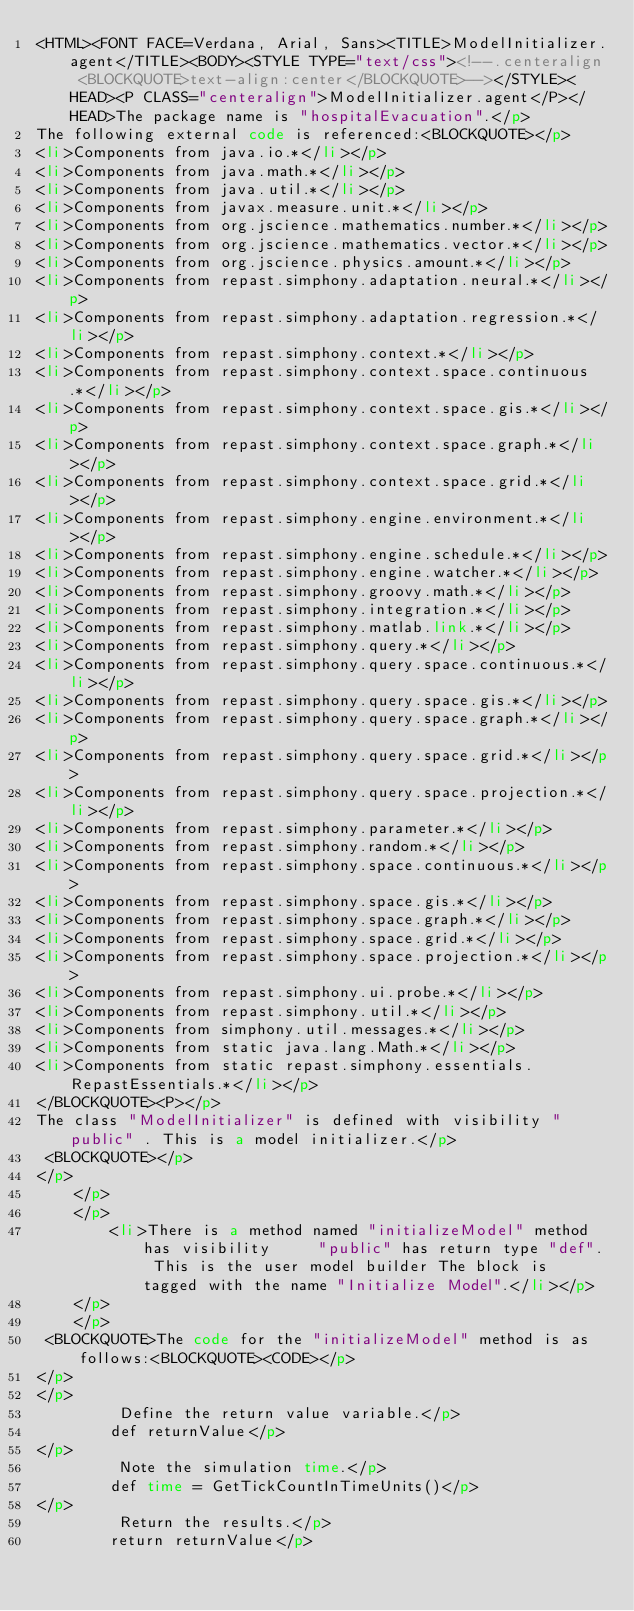Convert code to text. <code><loc_0><loc_0><loc_500><loc_500><_HTML_><HTML><FONT FACE=Verdana, Arial, Sans><TITLE>ModelInitializer.agent</TITLE><BODY><STYLE TYPE="text/css"><!--.centeralign <BLOCKQUOTE>text-align:center</BLOCKQUOTE>--></STYLE><HEAD><P CLASS="centeralign">ModelInitializer.agent</P></HEAD>The package name is "hospitalEvacuation".</p>
The following external code is referenced:<BLOCKQUOTE></p>
<li>Components from java.io.*</li></p>
<li>Components from java.math.*</li></p>
<li>Components from java.util.*</li></p>
<li>Components from javax.measure.unit.*</li></p>
<li>Components from org.jscience.mathematics.number.*</li></p>
<li>Components from org.jscience.mathematics.vector.*</li></p>
<li>Components from org.jscience.physics.amount.*</li></p>
<li>Components from repast.simphony.adaptation.neural.*</li></p>
<li>Components from repast.simphony.adaptation.regression.*</li></p>
<li>Components from repast.simphony.context.*</li></p>
<li>Components from repast.simphony.context.space.continuous.*</li></p>
<li>Components from repast.simphony.context.space.gis.*</li></p>
<li>Components from repast.simphony.context.space.graph.*</li></p>
<li>Components from repast.simphony.context.space.grid.*</li></p>
<li>Components from repast.simphony.engine.environment.*</li></p>
<li>Components from repast.simphony.engine.schedule.*</li></p>
<li>Components from repast.simphony.engine.watcher.*</li></p>
<li>Components from repast.simphony.groovy.math.*</li></p>
<li>Components from repast.simphony.integration.*</li></p>
<li>Components from repast.simphony.matlab.link.*</li></p>
<li>Components from repast.simphony.query.*</li></p>
<li>Components from repast.simphony.query.space.continuous.*</li></p>
<li>Components from repast.simphony.query.space.gis.*</li></p>
<li>Components from repast.simphony.query.space.graph.*</li></p>
<li>Components from repast.simphony.query.space.grid.*</li></p>
<li>Components from repast.simphony.query.space.projection.*</li></p>
<li>Components from repast.simphony.parameter.*</li></p>
<li>Components from repast.simphony.random.*</li></p>
<li>Components from repast.simphony.space.continuous.*</li></p>
<li>Components from repast.simphony.space.gis.*</li></p>
<li>Components from repast.simphony.space.graph.*</li></p>
<li>Components from repast.simphony.space.grid.*</li></p>
<li>Components from repast.simphony.space.projection.*</li></p>
<li>Components from repast.simphony.ui.probe.*</li></p>
<li>Components from repast.simphony.util.*</li></p>
<li>Components from simphony.util.messages.*</li></p>
<li>Components from static java.lang.Math.*</li></p>
<li>Components from static repast.simphony.essentials.RepastEssentials.*</li></p>
</BLOCKQUOTE><P></p>
The class "ModelInitializer" is defined with visibility "public" . This is a model initializer.</p>
 <BLOCKQUOTE></p>
</p>
    </p>
    </p>
        <li>There is a method named "initializeModel" method has visibility     "public" has return type "def". This is the user model builder The block is tagged with the name "Initialize Model".</li></p>
    </p>
    </p>
 <BLOCKQUOTE>The code for the "initializeModel" method is as follows:<BLOCKQUOTE><CODE></p>
</p>
</p>
         Define the return value variable.</p>
        def returnValue</p>
</p>
         Note the simulation time.</p>
        def time = GetTickCountInTimeUnits()</p>
</p>
         Return the results.</p>
        return returnValue</p></code> 